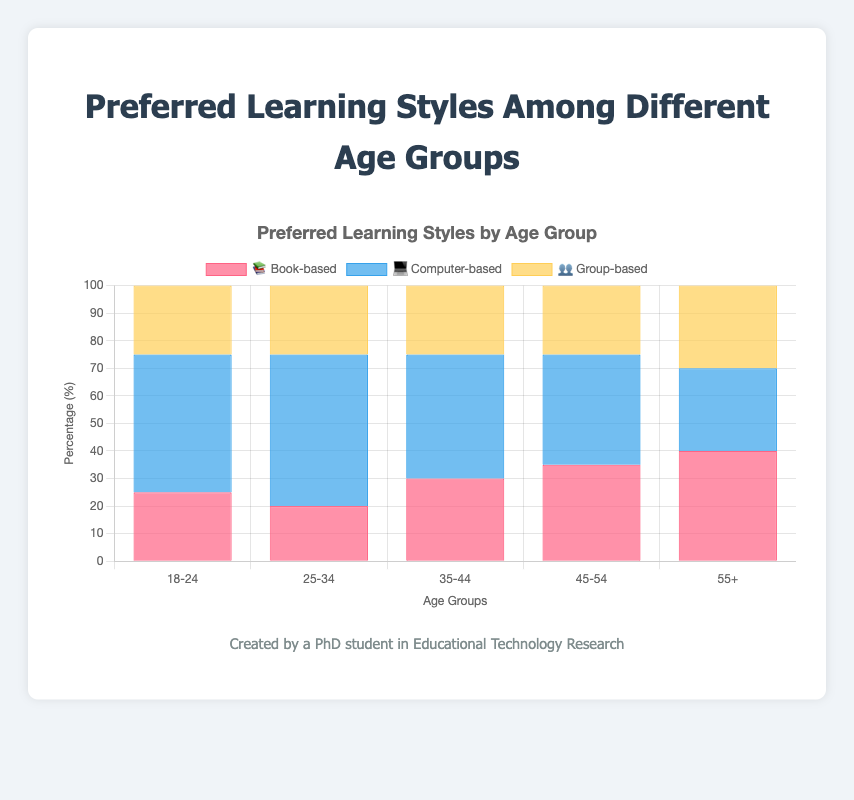What is the preferred learning style for the age group 18-24? The figure shows various age groups on the x-axis and their corresponding preferred learning styles on the y-axis. The age group 18-24 has bars for book-based, computer-based, and group-based preferences.
Answer: Computer-based Which age group prefers book-based learning the most? Look at the heights of the 📚 bars for each age group to determine which is the tallest.
Answer: 55+ How many age groups prefer computer-based learning more than book-based learning? Compare the heights of the 💻 and 📚 bars for each age group. Count the groups where the 💻 bar is taller than the 📚 bar.
Answer: 3 What's the total percentage of learners preferring group-based learning among all age groups? Sum the percentages of 👥 for each age group: 25 + 25 + 25 + 25 + 30.
Answer: 130% In which age group does group-based learning have the highest preference percentage? Identify the tallest 👥 bar across all age groups.
Answer: 55+ By how many percentage points does the preference for computer-based learning exceed group-based learning in the 25-34 age group? Subtract the percentage of group-based learning from computer-based learning in the 25-34 age group: 55 - 25.
Answer: 30 percentage points For which age groups are the percentages for book-based and group-based learning preferences equal? Compare the heights of the 📚 and 👥 bars for each age group and find where they are the same.
Answer: 18-24, 25-34, 35-44, 45-54 What is the average preference percentage for computer-based learning across all age groups? Sum the 💻 percentages and divide by the number of age groups: (50 + 55 + 45 + 40 + 30) / 5.
Answer: 44% Is there any age group where the preference for book-based learning exceeds computer-based learning? Check if any 📚 bar is taller than the corresponding 💻 bar.
Answer: Yes, in the age group 55+ Among the age groups 35-44 and 45-54, which has a higher preference for computer-based learning, and by how much? Compare the 💻 percentages: 45 for 35-44 and 40 for 45-54. Calculate the difference: 45 - 40.
Answer: 35-44 by 5 percentage points 